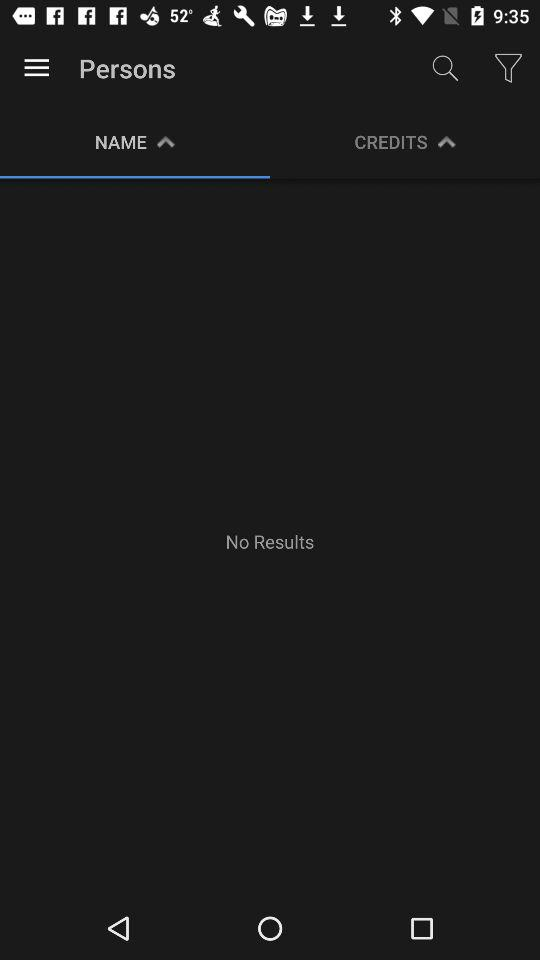Is there any result? There is no result. 